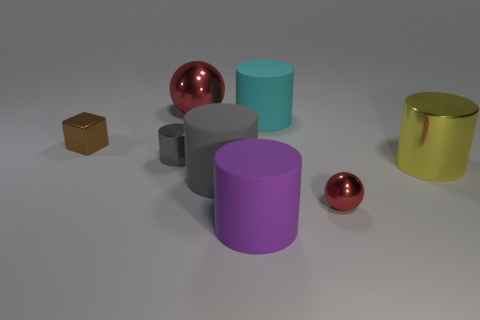Subtract 1 cylinders. How many cylinders are left? 4 Subtract all cyan cylinders. How many cylinders are left? 4 Subtract all small metallic cylinders. How many cylinders are left? 4 Subtract all blue cylinders. Subtract all blue balls. How many cylinders are left? 5 Add 1 large red metallic objects. How many objects exist? 9 Subtract all blocks. How many objects are left? 7 Subtract all gray blocks. Subtract all large yellow cylinders. How many objects are left? 7 Add 8 small spheres. How many small spheres are left? 9 Add 6 tiny blue rubber cylinders. How many tiny blue rubber cylinders exist? 6 Subtract 1 yellow cylinders. How many objects are left? 7 